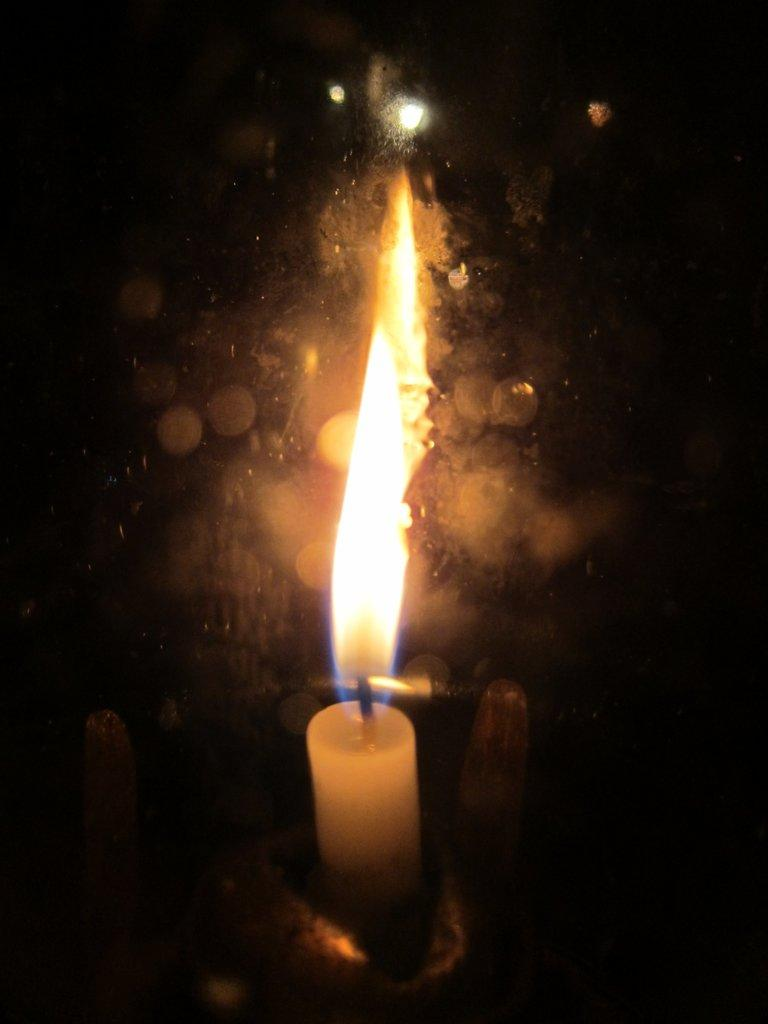What object is present in the image that can be lit? There is a white color candle in the image. What is the state of the candle in the image? There is fire in the image, which suggests that the candle is lit. What colors are predominant in the background of the image? The background of the image is orange and black. Can you see any quicksand in the image? There is no quicksand present in the image. Is there a jar visible in the image? There is no jar present in the image. Is there a woman in the image? There is no woman present in the image. 